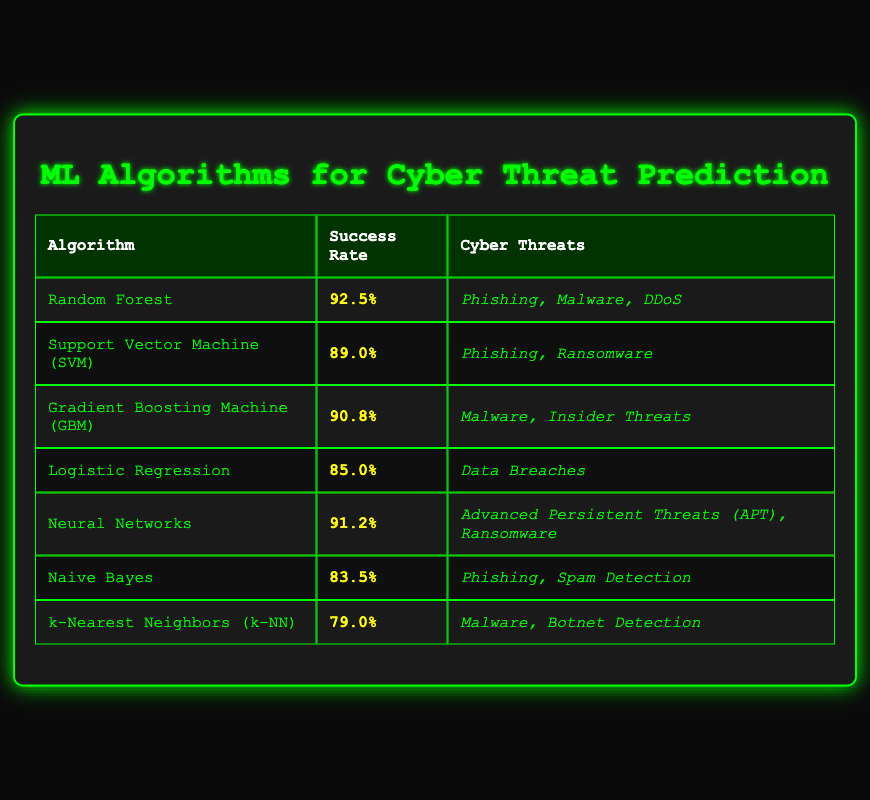What is the success rate of the Random Forest algorithm? The success rate for Random Forest is listed directly in the table as 92.5%.
Answer: 92.5% Which algorithms have a success rate over 90%? Looking at the success rates in the table, Random Forest (92.5%), Neural Networks (91.2%), and Gradient Boosting Machine (90.8%) are all over 90%.
Answer: Random Forest, Neural Networks, Gradient Boosting Machine What is the success rate of the Support Vector Machine (SVM) algorithm? In the table, the success rate for Support Vector Machine (SVM) is provided as 89.0%.
Answer: 89.0% Which cyber threats are predicted by Neural Networks? The table clearly states that Neural Networks predict Advanced Persistent Threats (APT) and Ransomware, so those are the cyber threats associated with this algorithm.
Answer: Advanced Persistent Threats (APT), Ransomware Is Naive Bayes successful in predicting Data Breaches? The table indicates that Naive Bayes predicts Phishing and Spam Detection, but does not mention Data Breaches, implying it is not successful for that threat.
Answer: No What is the average success rate of all listed algorithms? To find the average, sum all the success rates: 92.5 + 89.0 + 90.8 + 85.0 + 91.2 + 83.5 + 79.0 = 511.0. There are 7 algorithms, so the average is 511.0 / 7 = 73.0.
Answer: 73.0 Which algorithm has the lowest success rate? By comparing the success rates, k-Nearest Neighbors (k-NN) has the lowest success rate at 79.0%.
Answer: k-Nearest Neighbors (k-NN) Do both Gradient Boosting Machine (GBM) and Neural Networks predict Malware? The table shows that Malware is predicted by Gradient Boosting Machine (GBM) and is also listed for Neural Networks, confirming that both algorithms predict Malware.
Answer: Yes How many cyber threats does the Random Forest algorithm predict? The table lists three cyber threats associated with Random Forest: Phishing, Malware, and DDoS, hence it predicts three cyber threats.
Answer: Three 